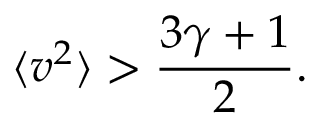Convert formula to latex. <formula><loc_0><loc_0><loc_500><loc_500>\langle v ^ { 2 } \rangle > \frac { 3 \gamma + 1 } { 2 } .</formula> 